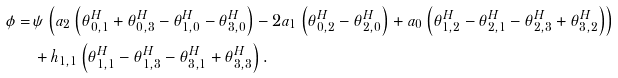Convert formula to latex. <formula><loc_0><loc_0><loc_500><loc_500>\phi = \, & \psi \left ( a _ { 2 } \left ( \theta ^ { H } _ { 0 , 1 } + \theta ^ { H } _ { 0 , 3 } - \theta ^ { H } _ { 1 , 0 } - \theta ^ { H } _ { 3 , 0 } \right ) - 2 a _ { 1 } \left ( \theta ^ { H } _ { 0 , 2 } - \theta ^ { H } _ { 2 , 0 } \right ) + a _ { 0 } \left ( \theta ^ { H } _ { 1 , 2 } - \theta ^ { H } _ { 2 , 1 } - \theta ^ { H } _ { 2 , 3 } + \theta ^ { H } _ { 3 , 2 } \right ) \right ) \\ & + h _ { 1 , 1 } \left ( \theta ^ { H } _ { 1 , 1 } - \theta ^ { H } _ { 1 , 3 } - \theta ^ { H } _ { 3 , 1 } + \theta ^ { H } _ { 3 , 3 } \right ) .</formula> 